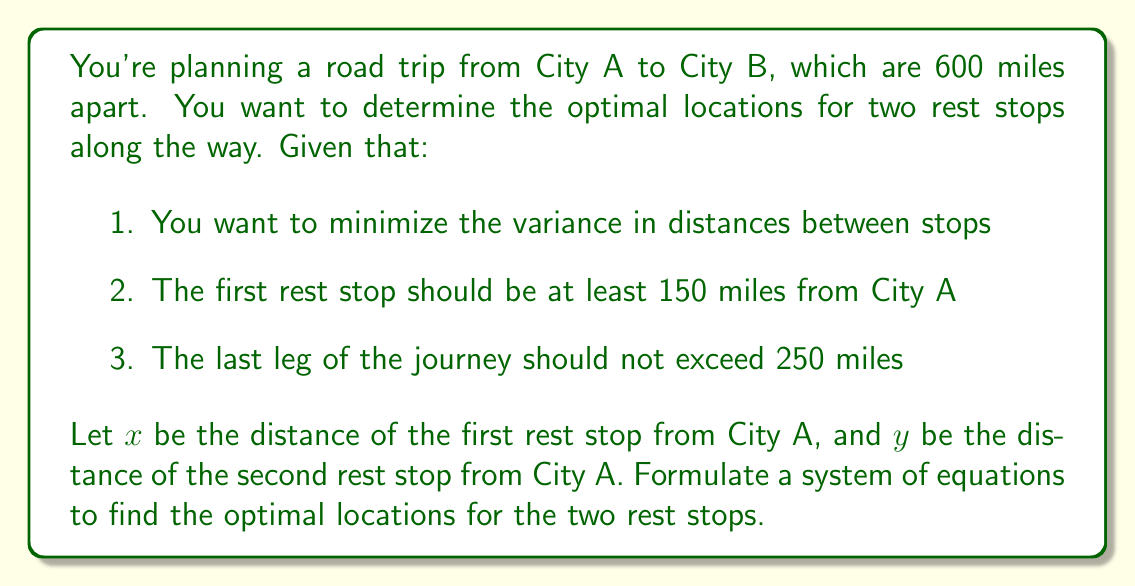Could you help me with this problem? To solve this problem, we need to set up a system of equations based on the given constraints and the goal of minimizing variance in distances between stops.

1. First, let's define our variables:
   $x$ = distance of first rest stop from City A
   $y$ = distance of second rest stop from City A

2. To minimize variance, we want the distances between each stop to be as equal as possible. This means:
   Distance from City A to first stop = Distance between stops = Distance from second stop to City B
   
   We can express this as:
   $$x = y - x = 600 - y$$

3. From the first equation, we can derive:
   $$y = 2x$$
   $$600 - y = x$$

4. Combining these equations:
   $$600 - 2x = x$$
   $$600 = 3x$$
   $$x = 200$$

5. Substituting back:
   $$y = 2x = 2(200) = 400$$

6. Now, let's check if these values satisfy the additional constraints:
   - First rest stop should be at least 150 miles from City A: $200 > 150$ (satisfied)
   - Last leg should not exceed 250 miles: $600 - 400 = 200 < 250$ (satisfied)

Therefore, the system of equations that describes this problem is:
$$\begin{cases}
y = 2x \\
600 - y = x
\end{cases}$$

This system, when solved, gives us the optimal locations for the two rest stops.
Answer: The optimal locations for the two rest stops are:
First rest stop: 200 miles from City A
Second rest stop: 400 miles from City A

The system of equations describing this problem is:
$$\begin{cases}
y = 2x \\
600 - y = x
\end{cases}$$ 